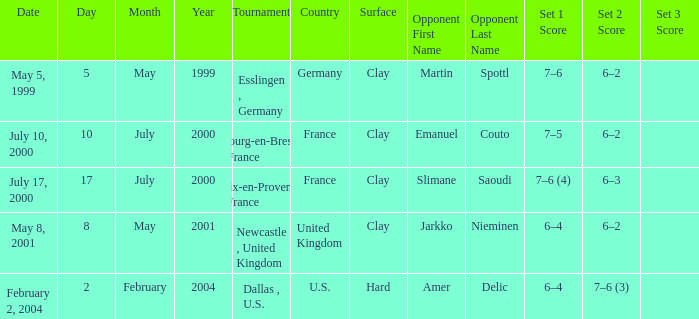What is the Score of the Tournament with Opponent in the final of Martin Spottl? 7–6, 6–2. 